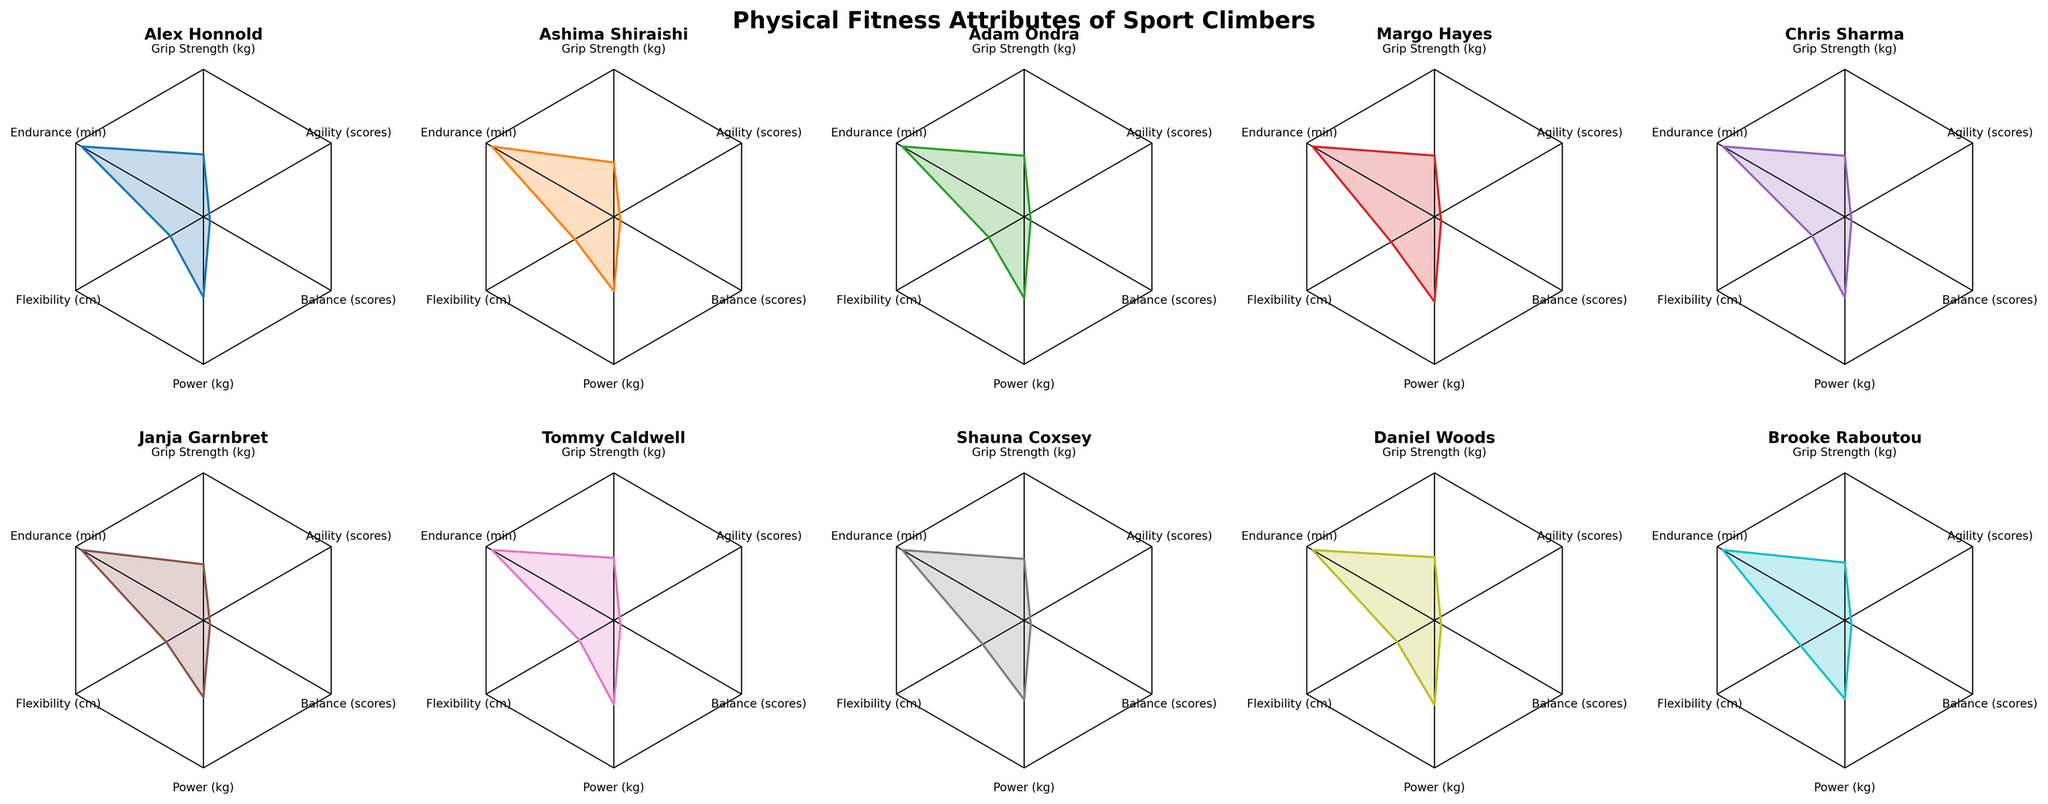Which climber has the highest endurance? To determine the climber with the most endurance, find the radar plot with the largest value for the 'Endurance (min)' axis. According to the data, Alex Honnold has the highest endurance level at 120 minutes.
Answer: Alex Honnold Between Chris Sharma and Janja Garnbret, who has better agility? Locate the plots for Chris Sharma and Janja Garnbret, and compare their values on the 'Agility (scores)' axis. Janja Garnbret has an agility score of 9.1, which is higher than Chris Sharma's score of 8.7.
Answer: Janja Garnbret Which climber has the highest balance score? Look at the radar plots, and identify the climber with the maximum value on the 'Balance (scores)' axis. Both Ashima Shiraishi and Janja Garnbret have the highest balance score of 9.8.
Answer: Ashima Shiraishi and Janja Garnbret What's the difference in grip strength between Alex Honnold and Ashima Shiraishi? Locate the plotted positions of Alex Honnold and Ashima Shiraishi on the 'Grip Strength (kg)' axis. Subtract Ashima’s grip strength (45 kg) from Alex's grip strength (55 kg). The difference is 10 kg.
Answer: 10 kg Which climber has the lowest flexibility? To find the climber with the lowest flexibility, look at the radar plots and identify the smallest value on the 'Flexibility (cm)' axis. Tommy Caldwell has the lowest flexibility at 33 cm.
Answer: Tommy Caldwell Who has both high power and high endurance? Analyze the plots to find climbers with high values on both the 'Power (kg)' and 'Endurance (min)' axes. Alex Honnold has high power (70 kg) and high endurance (120 min).
Answer: Alex Honnold What is the average score of agility for all climbers? Sum up the agility scores for all climbers (8.8 + 9.2 + 9.0 + 8.9 + 8.7 + 9.1 + 8.6 + 8.9 + 8.8 + 9.0) and divide by the number of climbers (10). The average score is 8.9.
Answer: 8.9 Which attribute shows the most variability across climbers? Compare the range of values for each attribute across all climbers in the radar plots. Flexibility shows the most variability with values ranging from 33 cm to 41 cm.
Answer: Flexibility Between Margo Hayes and Shauna Coxsey, who has better grip strength and flexibility combined? Locate Margo Hayes and Shauna Coxsey in the plots and add their 'Grip Strength (kg)' and 'Flexibility (cm)' values. Margo’s combined value is 48 kg + 40 cm = 88, while Shauna’s combined value is 49 kg + 39 cm = 88. Both have the same combined value.
Answer: Both Who has the median value for balance scores? Arrange the balance scores in ascending order (9.4, 9.5, 9.5, 9.5, 9.6, 9.6, 9.7, 9.7, 9.8, 9.8) and find the middle value(s). The median balance score is 9.6, so Margo Hayes and Shauna Coxsey have the median value.
Answer: Margo Hayes and Shauna Coxsey 